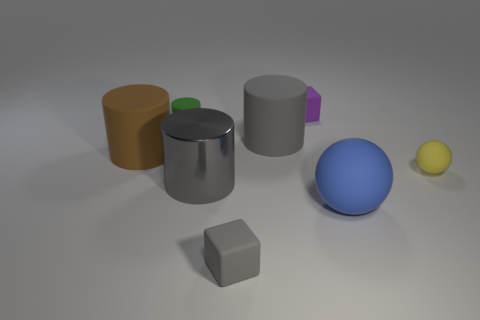Can you describe the textures and colors? Certainly! There are multiple textures and colors in the image. Starting with textures, you can observe objects with both matte and shiny surfaces. Color-wise, there's an assortment: the cylinders are orange and gray, and there's a matte green smaller cube atop the gray one. The larger cube is a matte blue, and the spheres are blue and yellow, with the yellow one being smaller. Lastly, there's a small matte gray cube as well. 